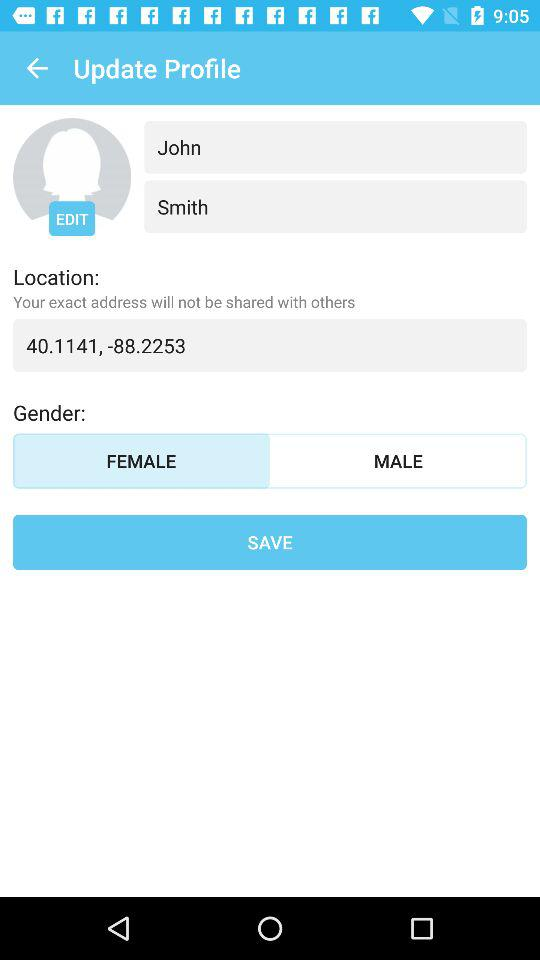What is the name of the user? The name of the user is John Smith. 